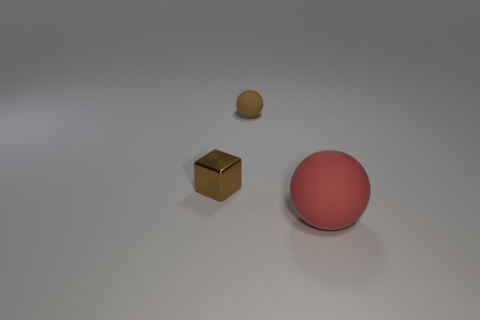There is a matte thing that is behind the metal block; how many balls are behind it?
Provide a short and direct response. 0. Do the small thing that is to the left of the brown rubber sphere and the rubber thing to the left of the large red ball have the same shape?
Ensure brevity in your answer.  No. There is a thing that is right of the small brown block and on the left side of the large matte object; what is its size?
Your response must be concise. Small. There is a tiny thing that is the same shape as the large red rubber object; what color is it?
Your response must be concise. Brown. The small object to the left of the brown thing that is to the right of the metallic thing is what color?
Your answer should be compact. Brown. What is the shape of the small brown shiny thing?
Provide a succinct answer. Cube. There is a object that is both to the right of the small shiny thing and behind the red object; what shape is it?
Your response must be concise. Sphere. What is the color of the ball that is the same material as the red object?
Your answer should be very brief. Brown. There is a tiny object left of the ball behind the red matte ball that is on the right side of the brown shiny object; what is its shape?
Your answer should be very brief. Cube. What size is the shiny block?
Your answer should be compact. Small. 